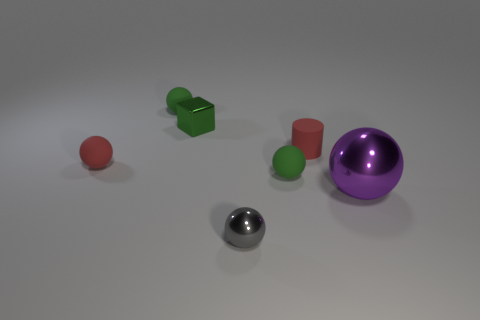Add 1 tiny green cubes. How many objects exist? 8 Subtract all cylinders. How many objects are left? 6 Subtract all small green matte spheres. Subtract all large balls. How many objects are left? 4 Add 2 green matte things. How many green matte things are left? 4 Add 5 tiny green metallic objects. How many tiny green metallic objects exist? 6 Subtract 0 brown cylinders. How many objects are left? 7 